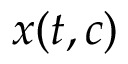<formula> <loc_0><loc_0><loc_500><loc_500>x ( t , c )</formula> 